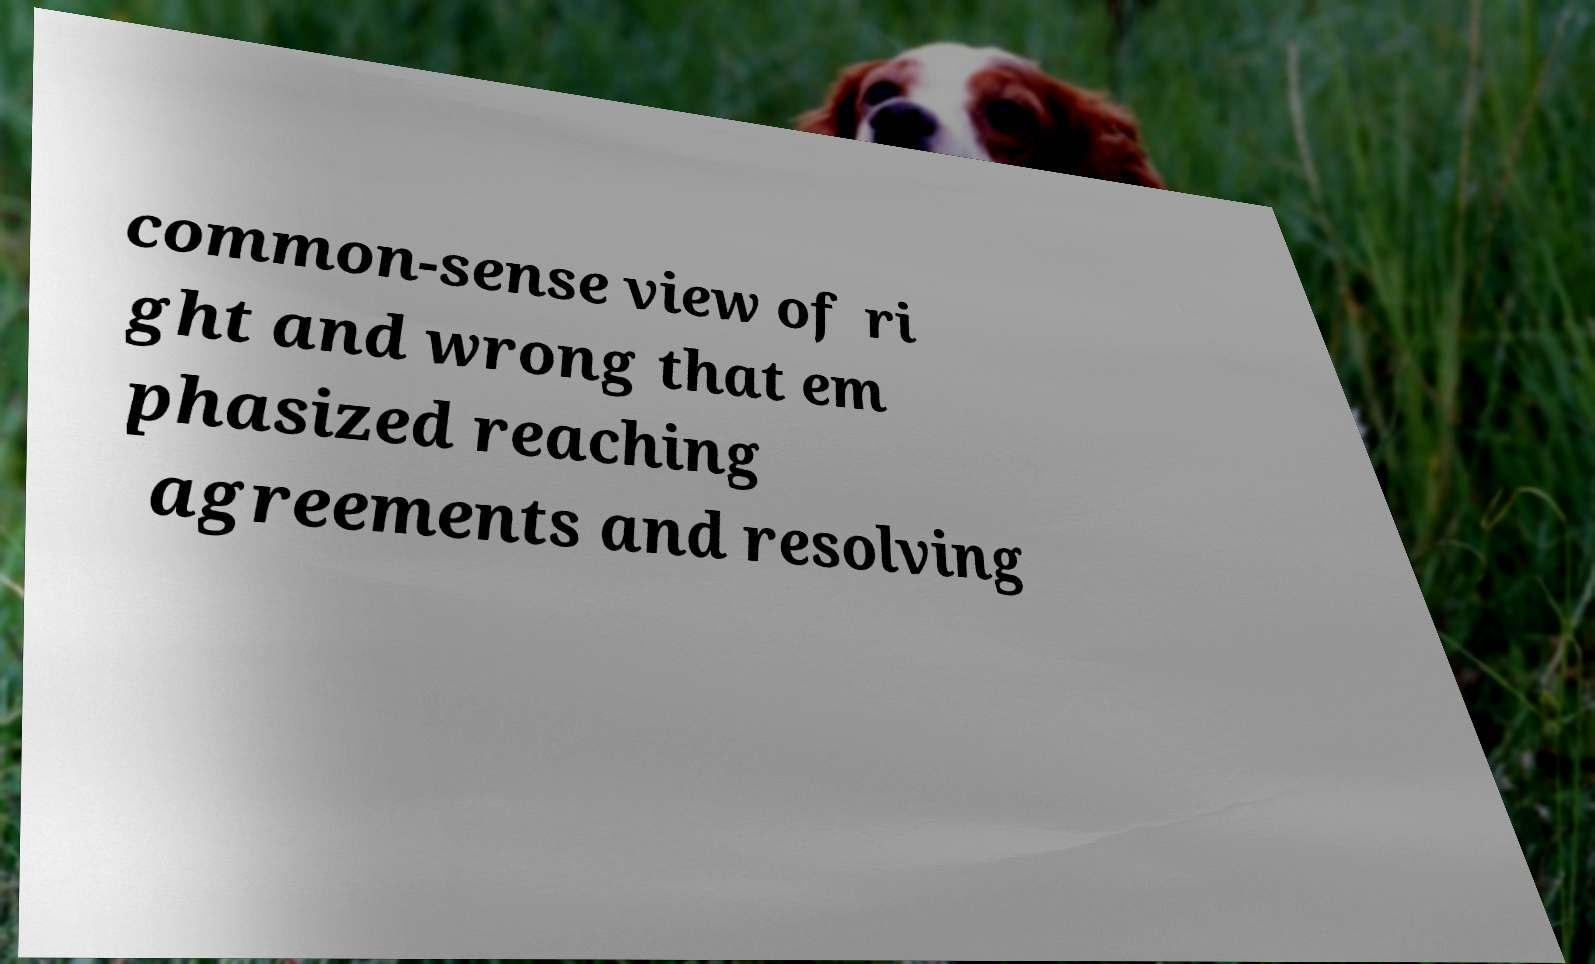Could you extract and type out the text from this image? common-sense view of ri ght and wrong that em phasized reaching agreements and resolving 